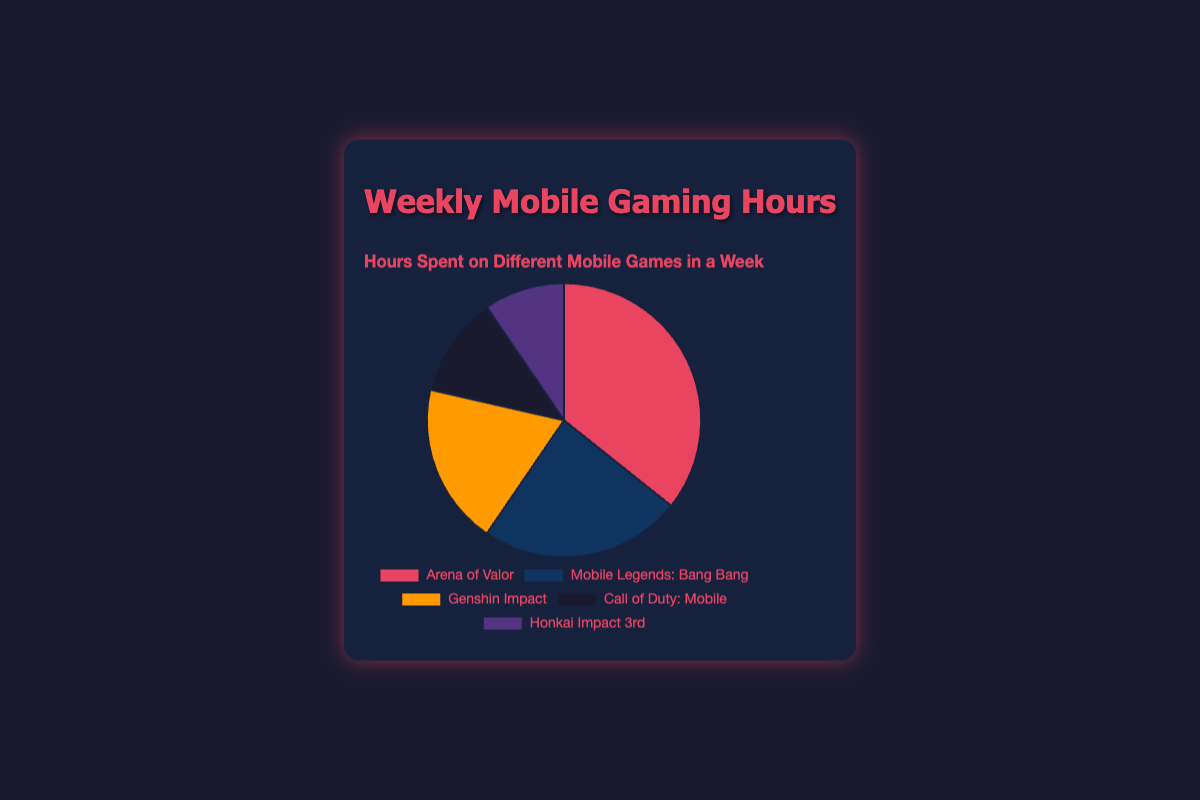What is the total number of hours spent on Arena of Valor and Genshin Impact combined? Arena of Valor has 15 hours, and Genshin Impact has 8 hours. Adding them up: 15 + 8 = 23 hours.
Answer: 23 Which game has the second highest number of hours spent? Arena of Valor has the highest with 15 hours, and Mobile Legends: Bang Bang is next with 10 hours.
Answer: Mobile Legends: Bang Bang What percentage of the total hours is spent on Call of Duty: Mobile? Total hours for all games is 15 + 10 + 8 + 5 + 4 = 42. The percentage is (5 / 42) * 100 ≈ 11.9%.
Answer: 11.9% Compare the hours spent on Mobile Legends: Bang Bang and Honkai Impact 3rd. Which one has more hours, and by how much? Mobile Legends: Bang Bang has 10 hours, while Honkai Impact 3rd has 4 hours. The difference is 10 - 4 = 6 hours.
Answer: Mobile Legends: Bang Bang by 6 hours What color represents Genshin Impact in the pie chart? According to the information provided, Genshin Impact is represented by the yellow section in the pie chart.
Answer: Yellow If the hours spent on Arena of Valor increased by 5 hours, what would be the new total hours for Arena of Valor? Arena of Valor originally has 15 hours. Adding 5 hours gives 15 + 5 = 20 hours.
Answer: 20 Which game has the least number of hours spent? Honkai Impact 3rd has the least number of hours spent with 4 hours.
Answer: Honkai Impact 3rd What is the average number of hours spent across all five games? Total hours are 15 + 10 + 8 + 5 + 4 = 42. The average is 42 / 5 = 8.4 hours.
Answer: 8.4 Is the difference in hours between Arena of Valor and Mobile Legends: Bang Bang less than the hours spent on Genshin Impact? The difference between Arena of Valor (15) and Mobile Legends: Bang Bang (10) is 15 - 10 = 5. Hours spent on Genshin Impact are 8. Yes, 5 is less than 8.
Answer: Yes How many more hours are spent on Arena of Valor compared to the combined hours of Call of Duty: Mobile and Honkai Impact 3rd? Arena of Valor has 15 hours. Call of Duty: Mobile has 5 hours, and Honkai Impact 3rd has 4 hours. Combined hours of these two games are 5 + 4 = 9. The difference is 15 - 9 = 6 hours.
Answer: 6 